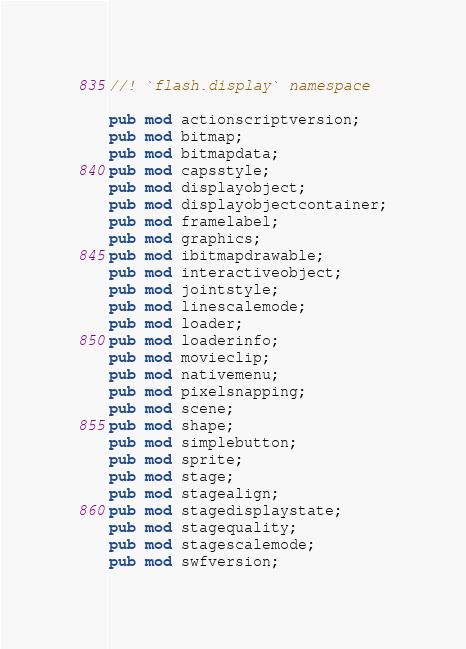Convert code to text. <code><loc_0><loc_0><loc_500><loc_500><_Rust_>//! `flash.display` namespace

pub mod actionscriptversion;
pub mod bitmap;
pub mod bitmapdata;
pub mod capsstyle;
pub mod displayobject;
pub mod displayobjectcontainer;
pub mod framelabel;
pub mod graphics;
pub mod ibitmapdrawable;
pub mod interactiveobject;
pub mod jointstyle;
pub mod linescalemode;
pub mod loader;
pub mod loaderinfo;
pub mod movieclip;
pub mod nativemenu;
pub mod pixelsnapping;
pub mod scene;
pub mod shape;
pub mod simplebutton;
pub mod sprite;
pub mod stage;
pub mod stagealign;
pub mod stagedisplaystate;
pub mod stagequality;
pub mod stagescalemode;
pub mod swfversion;
</code> 